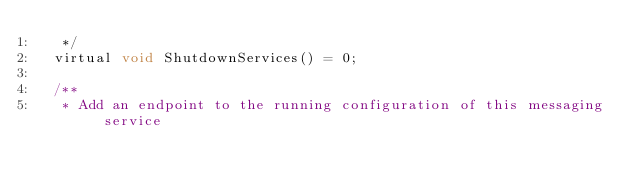<code> <loc_0><loc_0><loc_500><loc_500><_C_>	 */
	virtual void ShutdownServices() = 0;

	/**
	 * Add an endpoint to the running configuration of this messaging service</code> 